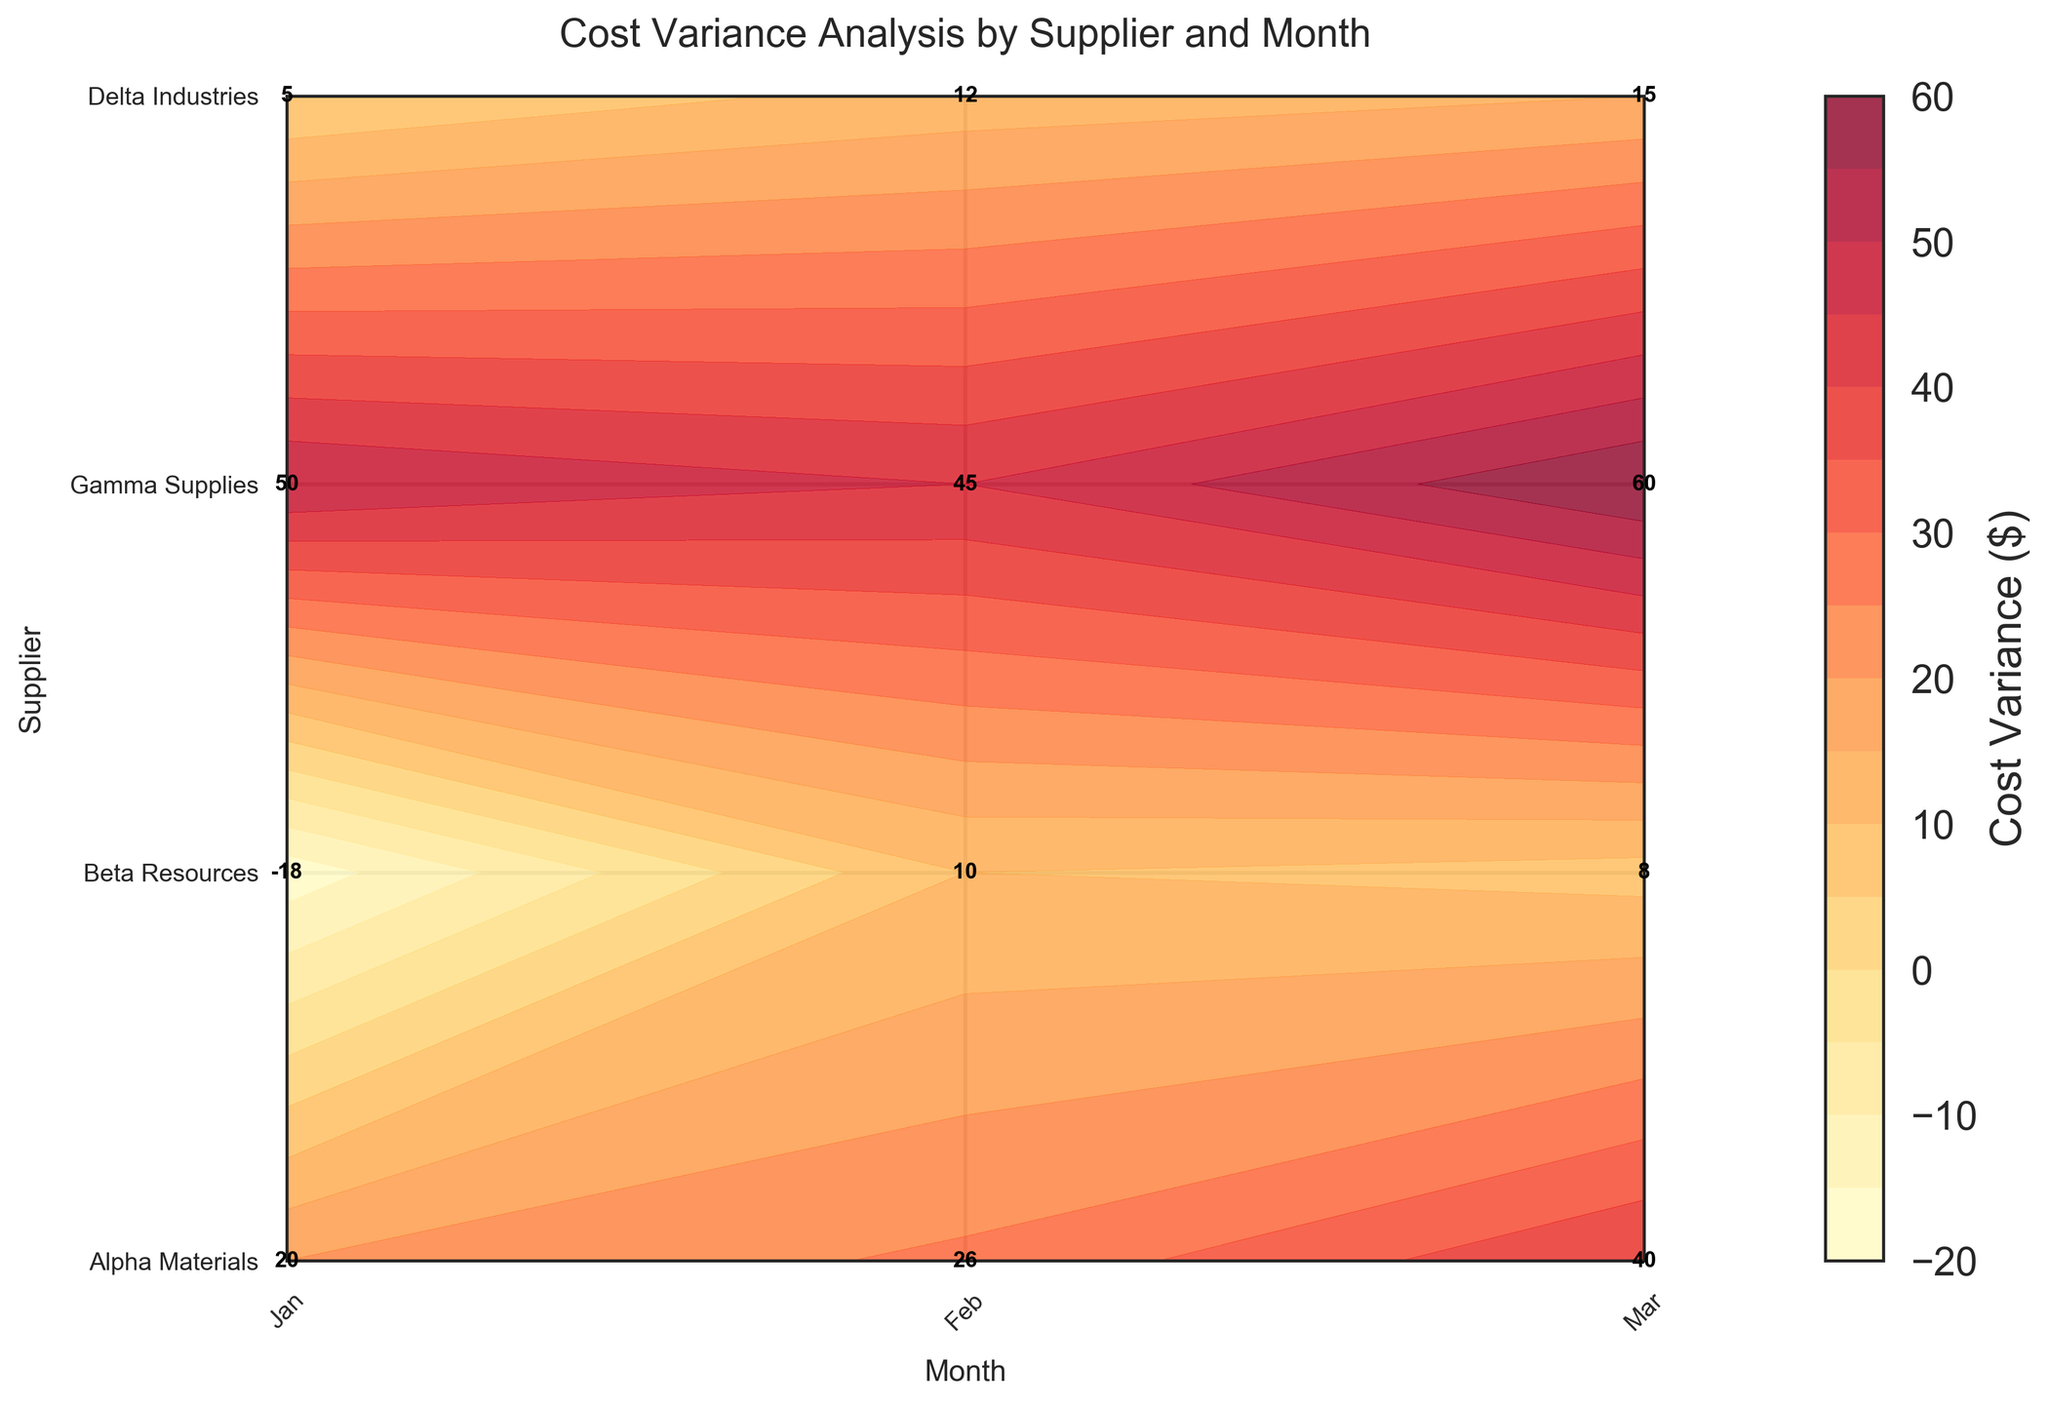What is the highest cost variance for Gamma Supplies? Look for the cell corresponding to Gamma Supplies in the table, and identify the highest cost variance value visible. It's 60.
Answer: 60 Which month shows the highest cost variance for all suppliers combined? Sum the cost variance across all suppliers for each month: Jan (20 - 18 + 50 + 5 = 57), Feb (26 + 10 + 45 + 12 = 93), Mar (40 + 8 + 60 + 15 = 123). March has the highest combined variance.
Answer: March Which supplier has the most positive cost variance in February? Check the cost variance values for each supplier in February. Gamma Supplies has the highest positive cost variance of 45.
Answer: Gamma Supplies Is Beta Resources' cost variance positive or negative in January? Check the cost variance value corresponding to Beta Resources in January. It's -18, which is negative.
Answer: Negative What is the average cost variance for Alpha Materials across all months? To calculate the average, sum the cost variance values for Alpha Materials (20 + 26 + 40) and divide by 3. The average is (20 + 26 + 40) / 3 = 28.67.
Answer: 28.67 How does Delta Industries' cost variance in March compare to its Jan cost variance? Check the cost variance values for Delta Industries in March (15) and January (5). The March variance is 15, which is 10 more than January's variance.
Answer: 10 more Which supplier shows the least variability in cost variance across the three months? Calculate the range (max - min) of cost variance for each supplier. Alpha Materials: 40 - 20 = 20; Beta Resources: 10 - (-18) = 28; Gamma Supplies: 60 - 45 = 15; Delta Industries: 15 - 5 = 10. Delta Industries has the least variability.
Answer: Delta Industries Does any supplier show a negative cost variance across all months? Inspect the cost variance values for each supplier across all months. Beta Resources shows a negative cost variance only in January, so no supplier has negative cost variance in all months.
Answer: No Which month shows the least cost variance for Alpha Materials? Compare the cost variance values for Alpha Materials in each month: Jan (20), Feb (26), Mar (40). January has the least cost variance.
Answer: January 